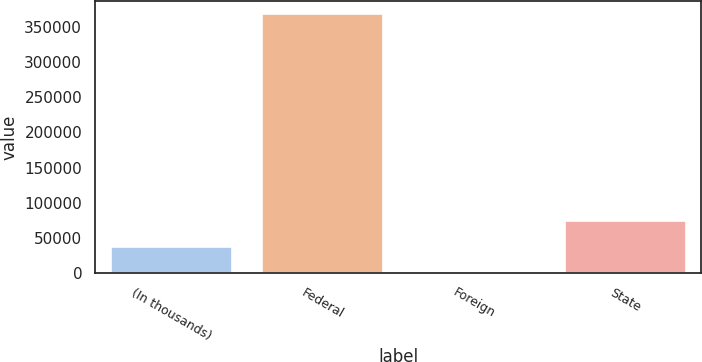Convert chart to OTSL. <chart><loc_0><loc_0><loc_500><loc_500><bar_chart><fcel>(In thousands)<fcel>Federal<fcel>Foreign<fcel>State<nl><fcel>36936.9<fcel>368451<fcel>102<fcel>73771.8<nl></chart> 